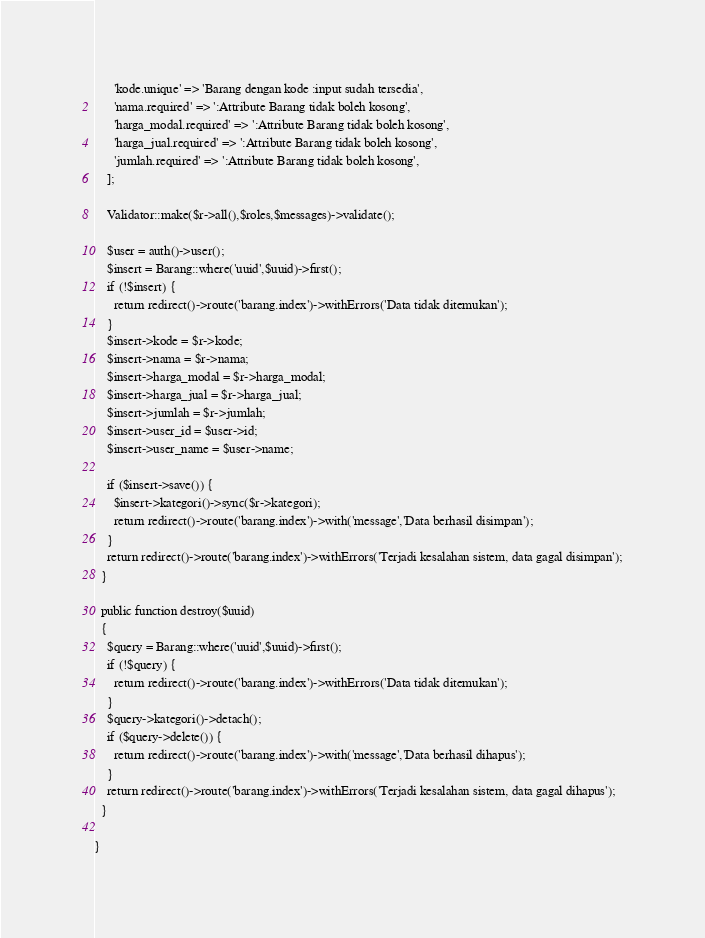<code> <loc_0><loc_0><loc_500><loc_500><_PHP_>      'kode.unique' => 'Barang dengan kode :input sudah tersedia',
      'nama.required' => ':Attribute Barang tidak boleh kosong',
      'harga_modal.required' => ':Attribute Barang tidak boleh kosong',
      'harga_jual.required' => ':Attribute Barang tidak boleh kosong',
      'jumlah.required' => ':Attribute Barang tidak boleh kosong',
    ];

    Validator::make($r->all(),$roles,$messages)->validate();

    $user = auth()->user();
    $insert = Barang::where('uuid',$uuid)->first();
    if (!$insert) {
      return redirect()->route('barang.index')->withErrors('Data tidak ditemukan');
    }
    $insert->kode = $r->kode;
    $insert->nama = $r->nama;
    $insert->harga_modal = $r->harga_modal;
    $insert->harga_jual = $r->harga_jual;
    $insert->jumlah = $r->jumlah;
    $insert->user_id = $user->id;
    $insert->user_name = $user->name;

    if ($insert->save()) {
      $insert->kategori()->sync($r->kategori);
      return redirect()->route('barang.index')->with('message','Data berhasil disimpan');
    }
    return redirect()->route('barang.index')->withErrors('Terjadi kesalahan sistem, data gagal disimpan');
  }

  public function destroy($uuid)
  {
    $query = Barang::where('uuid',$uuid)->first();
    if (!$query) {
      return redirect()->route('barang.index')->withErrors('Data tidak ditemukan');
    }
    $query->kategori()->detach();
    if ($query->delete()) {
      return redirect()->route('barang.index')->with('message','Data berhasil dihapus');
    }
    return redirect()->route('barang.index')->withErrors('Terjadi kesalahan sistem, data gagal dihapus');
  }

}
</code> 